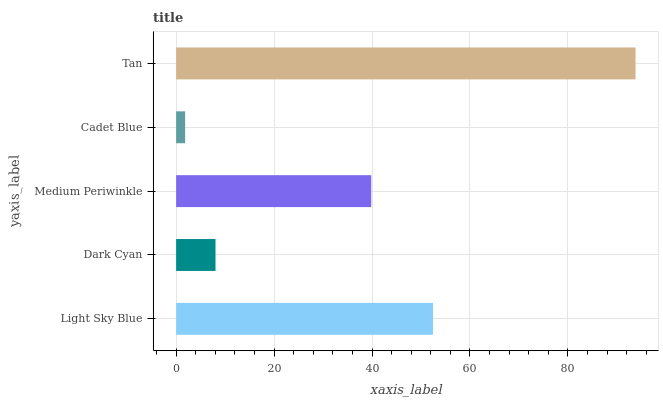Is Cadet Blue the minimum?
Answer yes or no. Yes. Is Tan the maximum?
Answer yes or no. Yes. Is Dark Cyan the minimum?
Answer yes or no. No. Is Dark Cyan the maximum?
Answer yes or no. No. Is Light Sky Blue greater than Dark Cyan?
Answer yes or no. Yes. Is Dark Cyan less than Light Sky Blue?
Answer yes or no. Yes. Is Dark Cyan greater than Light Sky Blue?
Answer yes or no. No. Is Light Sky Blue less than Dark Cyan?
Answer yes or no. No. Is Medium Periwinkle the high median?
Answer yes or no. Yes. Is Medium Periwinkle the low median?
Answer yes or no. Yes. Is Dark Cyan the high median?
Answer yes or no. No. Is Dark Cyan the low median?
Answer yes or no. No. 